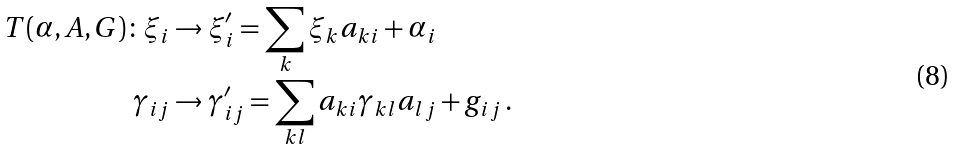<formula> <loc_0><loc_0><loc_500><loc_500>T ( \alpha , A , G ) \colon \xi _ { i } & \to \xi _ { i } ^ { \prime } = \sum _ { k } \xi _ { k } a _ { k i } + \alpha _ { i } \\ \gamma _ { i j } & \to \gamma _ { i j } ^ { \prime } = \sum _ { k l } a _ { k i } \gamma _ { k l } a _ { l j } + g _ { i j } \, .</formula> 